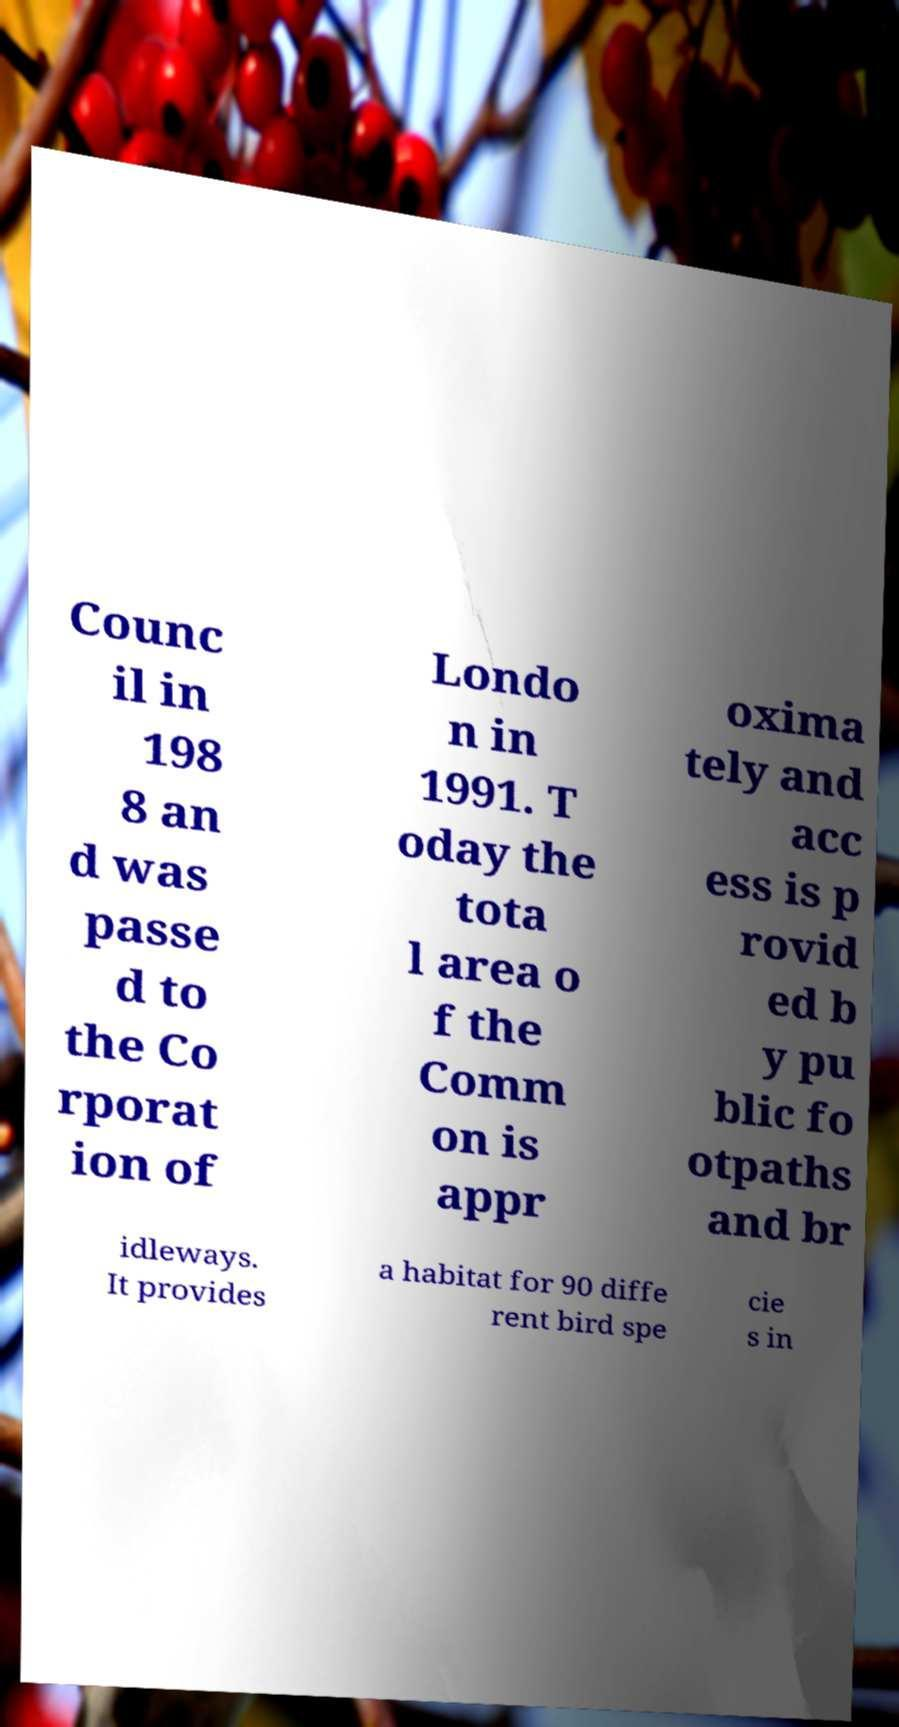What messages or text are displayed in this image? I need them in a readable, typed format. Counc il in 198 8 an d was passe d to the Co rporat ion of Londo n in 1991. T oday the tota l area o f the Comm on is appr oxima tely and acc ess is p rovid ed b y pu blic fo otpaths and br idleways. It provides a habitat for 90 diffe rent bird spe cie s in 